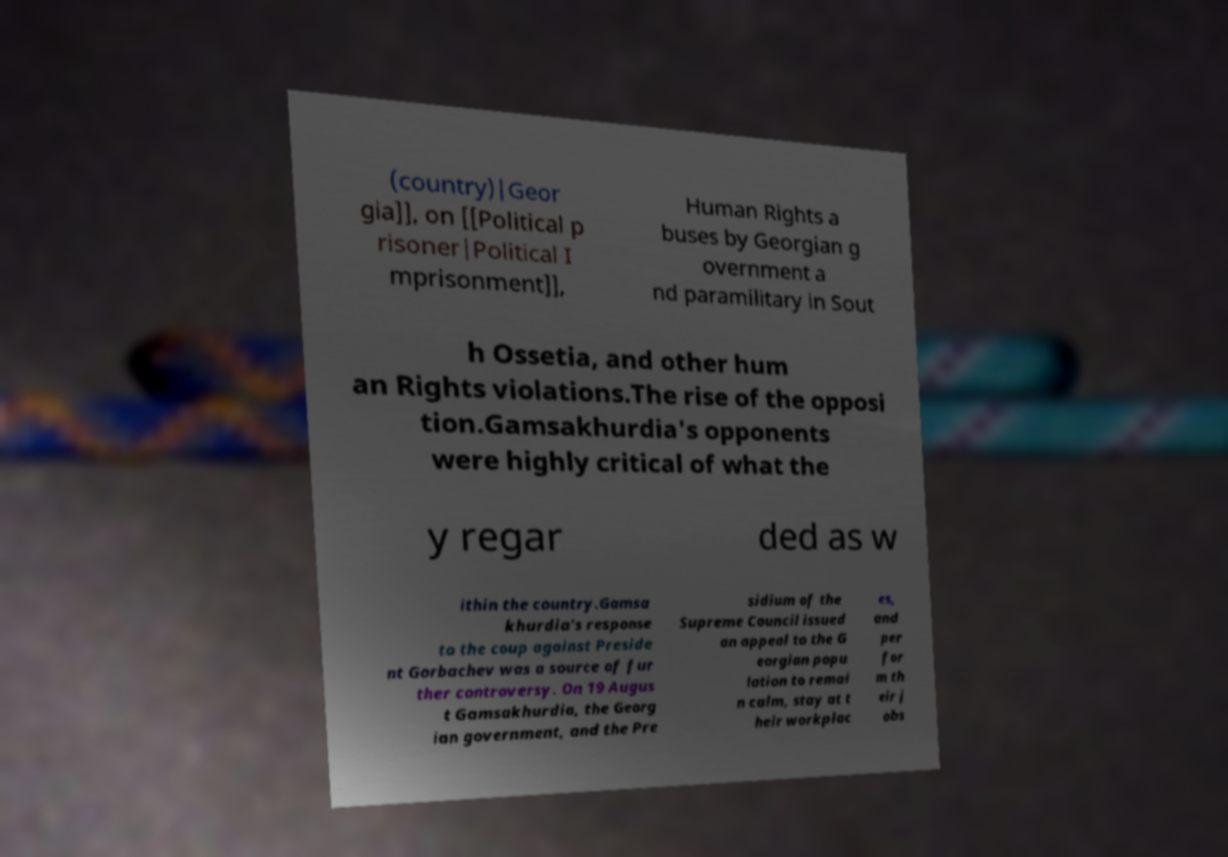Please read and relay the text visible in this image. What does it say? (country)|Geor gia]], on [[Political p risoner|Political I mprisonment]], Human Rights a buses by Georgian g overnment a nd paramilitary in Sout h Ossetia, and other hum an Rights violations.The rise of the opposi tion.Gamsakhurdia's opponents were highly critical of what the y regar ded as w ithin the country.Gamsa khurdia's response to the coup against Preside nt Gorbachev was a source of fur ther controversy. On 19 Augus t Gamsakhurdia, the Georg ian government, and the Pre sidium of the Supreme Council issued an appeal to the G eorgian popu lation to remai n calm, stay at t heir workplac es, and per for m th eir j obs 